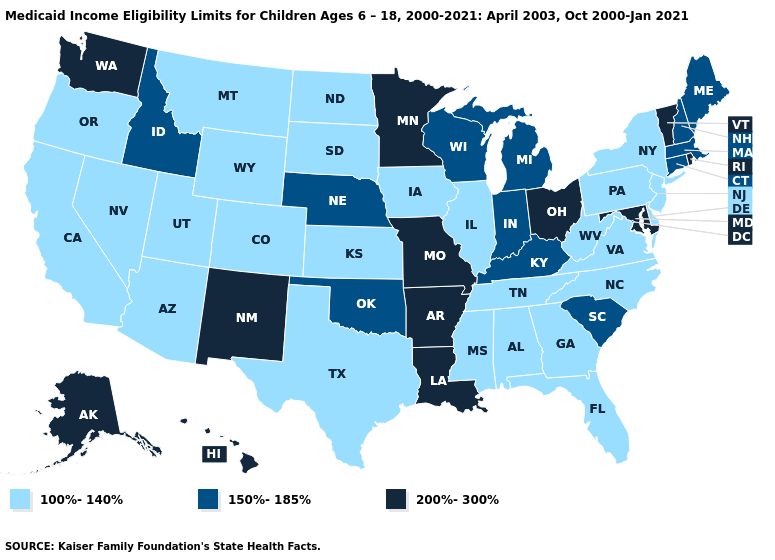Which states have the lowest value in the USA?
Give a very brief answer. Alabama, Arizona, California, Colorado, Delaware, Florida, Georgia, Illinois, Iowa, Kansas, Mississippi, Montana, Nevada, New Jersey, New York, North Carolina, North Dakota, Oregon, Pennsylvania, South Dakota, Tennessee, Texas, Utah, Virginia, West Virginia, Wyoming. Does Wyoming have the same value as Wisconsin?
Give a very brief answer. No. Name the states that have a value in the range 150%-185%?
Keep it brief. Connecticut, Idaho, Indiana, Kentucky, Maine, Massachusetts, Michigan, Nebraska, New Hampshire, Oklahoma, South Carolina, Wisconsin. What is the lowest value in the USA?
Answer briefly. 100%-140%. Name the states that have a value in the range 150%-185%?
Short answer required. Connecticut, Idaho, Indiana, Kentucky, Maine, Massachusetts, Michigan, Nebraska, New Hampshire, Oklahoma, South Carolina, Wisconsin. What is the lowest value in the MidWest?
Write a very short answer. 100%-140%. What is the value of Florida?
Write a very short answer. 100%-140%. Does Vermont have the lowest value in the USA?
Concise answer only. No. Does New York have the highest value in the Northeast?
Keep it brief. No. Does Nebraska have a higher value than Connecticut?
Be succinct. No. Among the states that border Nevada , which have the highest value?
Concise answer only. Idaho. Does Kentucky have a lower value than Virginia?
Quick response, please. No. What is the value of Colorado?
Be succinct. 100%-140%. What is the lowest value in the Northeast?
Give a very brief answer. 100%-140%. What is the highest value in the USA?
Write a very short answer. 200%-300%. 